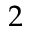<formula> <loc_0><loc_0><loc_500><loc_500>2</formula> 